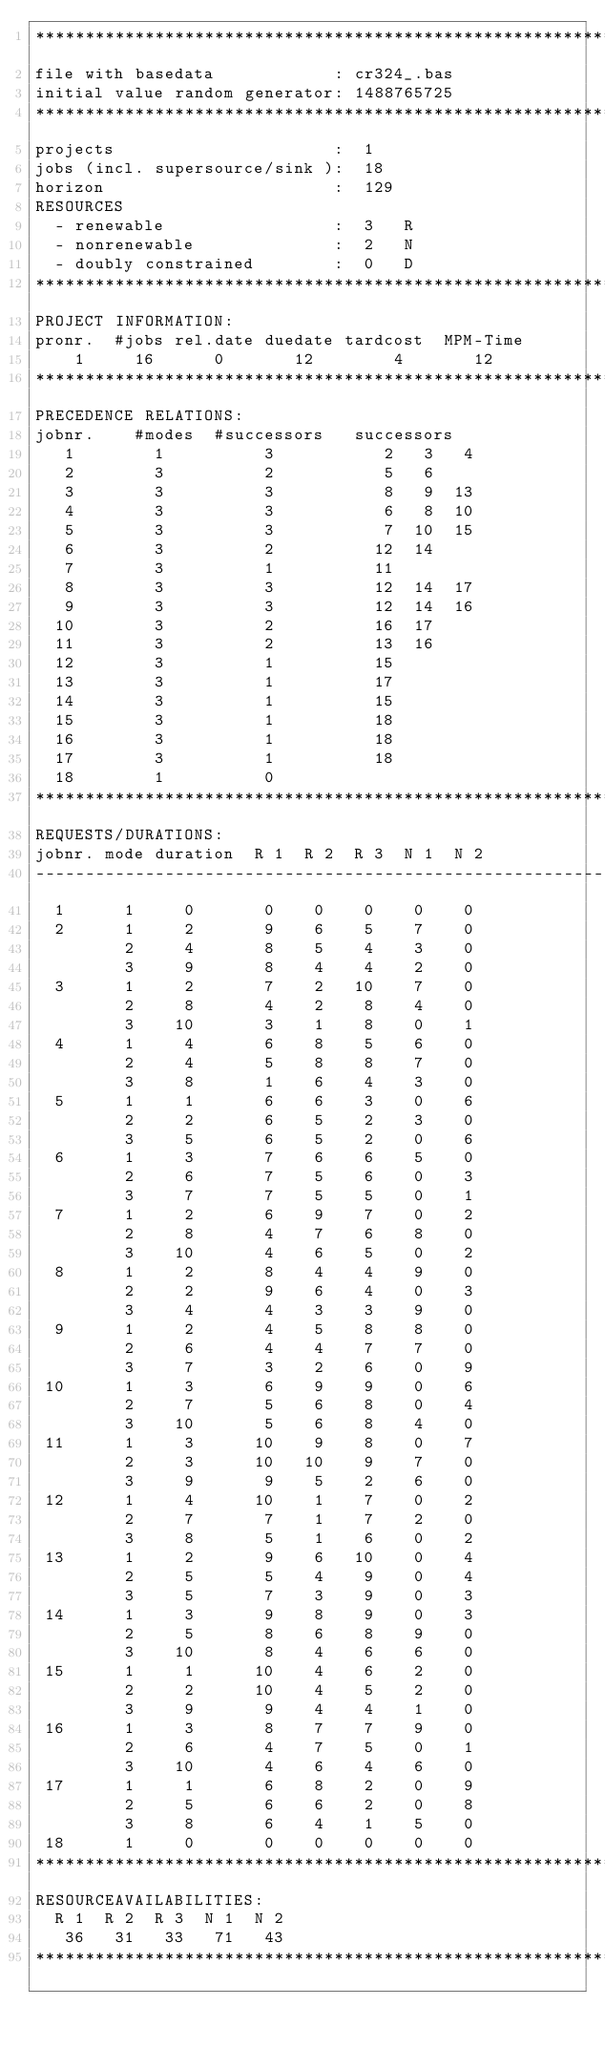<code> <loc_0><loc_0><loc_500><loc_500><_ObjectiveC_>************************************************************************
file with basedata            : cr324_.bas
initial value random generator: 1488765725
************************************************************************
projects                      :  1
jobs (incl. supersource/sink ):  18
horizon                       :  129
RESOURCES
  - renewable                 :  3   R
  - nonrenewable              :  2   N
  - doubly constrained        :  0   D
************************************************************************
PROJECT INFORMATION:
pronr.  #jobs rel.date duedate tardcost  MPM-Time
    1     16      0       12        4       12
************************************************************************
PRECEDENCE RELATIONS:
jobnr.    #modes  #successors   successors
   1        1          3           2   3   4
   2        3          2           5   6
   3        3          3           8   9  13
   4        3          3           6   8  10
   5        3          3           7  10  15
   6        3          2          12  14
   7        3          1          11
   8        3          3          12  14  17
   9        3          3          12  14  16
  10        3          2          16  17
  11        3          2          13  16
  12        3          1          15
  13        3          1          17
  14        3          1          15
  15        3          1          18
  16        3          1          18
  17        3          1          18
  18        1          0        
************************************************************************
REQUESTS/DURATIONS:
jobnr. mode duration  R 1  R 2  R 3  N 1  N 2
------------------------------------------------------------------------
  1      1     0       0    0    0    0    0
  2      1     2       9    6    5    7    0
         2     4       8    5    4    3    0
         3     9       8    4    4    2    0
  3      1     2       7    2   10    7    0
         2     8       4    2    8    4    0
         3    10       3    1    8    0    1
  4      1     4       6    8    5    6    0
         2     4       5    8    8    7    0
         3     8       1    6    4    3    0
  5      1     1       6    6    3    0    6
         2     2       6    5    2    3    0
         3     5       6    5    2    0    6
  6      1     3       7    6    6    5    0
         2     6       7    5    6    0    3
         3     7       7    5    5    0    1
  7      1     2       6    9    7    0    2
         2     8       4    7    6    8    0
         3    10       4    6    5    0    2
  8      1     2       8    4    4    9    0
         2     2       9    6    4    0    3
         3     4       4    3    3    9    0
  9      1     2       4    5    8    8    0
         2     6       4    4    7    7    0
         3     7       3    2    6    0    9
 10      1     3       6    9    9    0    6
         2     7       5    6    8    0    4
         3    10       5    6    8    4    0
 11      1     3      10    9    8    0    7
         2     3      10   10    9    7    0
         3     9       9    5    2    6    0
 12      1     4      10    1    7    0    2
         2     7       7    1    7    2    0
         3     8       5    1    6    0    2
 13      1     2       9    6   10    0    4
         2     5       5    4    9    0    4
         3     5       7    3    9    0    3
 14      1     3       9    8    9    0    3
         2     5       8    6    8    9    0
         3    10       8    4    6    6    0
 15      1     1      10    4    6    2    0
         2     2      10    4    5    2    0
         3     9       9    4    4    1    0
 16      1     3       8    7    7    9    0
         2     6       4    7    5    0    1
         3    10       4    6    4    6    0
 17      1     1       6    8    2    0    9
         2     5       6    6    2    0    8
         3     8       6    4    1    5    0
 18      1     0       0    0    0    0    0
************************************************************************
RESOURCEAVAILABILITIES:
  R 1  R 2  R 3  N 1  N 2
   36   31   33   71   43
************************************************************************
</code> 